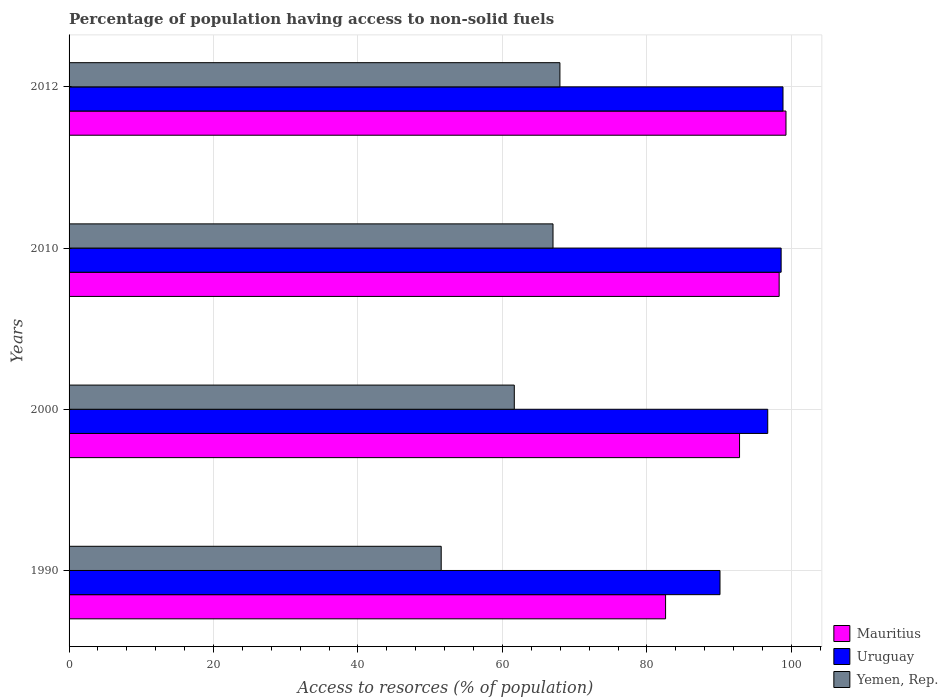How many groups of bars are there?
Your answer should be compact. 4. Are the number of bars on each tick of the Y-axis equal?
Your response must be concise. Yes. How many bars are there on the 1st tick from the top?
Give a very brief answer. 3. What is the label of the 2nd group of bars from the top?
Ensure brevity in your answer.  2010. In how many cases, is the number of bars for a given year not equal to the number of legend labels?
Make the answer very short. 0. What is the percentage of population having access to non-solid fuels in Mauritius in 2012?
Provide a short and direct response. 99.26. Across all years, what is the maximum percentage of population having access to non-solid fuels in Yemen, Rep.?
Ensure brevity in your answer.  67.96. Across all years, what is the minimum percentage of population having access to non-solid fuels in Uruguay?
Ensure brevity in your answer.  90.12. In which year was the percentage of population having access to non-solid fuels in Mauritius maximum?
Your answer should be compact. 2012. What is the total percentage of population having access to non-solid fuels in Uruguay in the graph?
Offer a very short reply. 384.29. What is the difference between the percentage of population having access to non-solid fuels in Uruguay in 1990 and that in 2012?
Keep it short and to the point. -8.72. What is the difference between the percentage of population having access to non-solid fuels in Yemen, Rep. in 1990 and the percentage of population having access to non-solid fuels in Uruguay in 2010?
Your answer should be very brief. -47.06. What is the average percentage of population having access to non-solid fuels in Uruguay per year?
Your answer should be compact. 96.07. In the year 2012, what is the difference between the percentage of population having access to non-solid fuels in Yemen, Rep. and percentage of population having access to non-solid fuels in Mauritius?
Make the answer very short. -31.3. In how many years, is the percentage of population having access to non-solid fuels in Uruguay greater than 4 %?
Make the answer very short. 4. What is the ratio of the percentage of population having access to non-solid fuels in Mauritius in 1990 to that in 2012?
Give a very brief answer. 0.83. Is the difference between the percentage of population having access to non-solid fuels in Yemen, Rep. in 1990 and 2000 greater than the difference between the percentage of population having access to non-solid fuels in Mauritius in 1990 and 2000?
Offer a terse response. Yes. What is the difference between the highest and the second highest percentage of population having access to non-solid fuels in Uruguay?
Ensure brevity in your answer.  0.26. What is the difference between the highest and the lowest percentage of population having access to non-solid fuels in Uruguay?
Ensure brevity in your answer.  8.72. In how many years, is the percentage of population having access to non-solid fuels in Uruguay greater than the average percentage of population having access to non-solid fuels in Uruguay taken over all years?
Your answer should be very brief. 3. Is the sum of the percentage of population having access to non-solid fuels in Uruguay in 1990 and 2000 greater than the maximum percentage of population having access to non-solid fuels in Yemen, Rep. across all years?
Give a very brief answer. Yes. What does the 3rd bar from the top in 2010 represents?
Your answer should be compact. Mauritius. What does the 2nd bar from the bottom in 1990 represents?
Your answer should be very brief. Uruguay. How many years are there in the graph?
Offer a very short reply. 4. What is the difference between two consecutive major ticks on the X-axis?
Make the answer very short. 20. Are the values on the major ticks of X-axis written in scientific E-notation?
Your response must be concise. No. Does the graph contain any zero values?
Your answer should be very brief. No. Does the graph contain grids?
Ensure brevity in your answer.  Yes. How many legend labels are there?
Offer a terse response. 3. What is the title of the graph?
Your response must be concise. Percentage of population having access to non-solid fuels. What is the label or title of the X-axis?
Provide a succinct answer. Access to resorces (% of population). What is the Access to resorces (% of population) in Mauritius in 1990?
Your answer should be very brief. 82.59. What is the Access to resorces (% of population) of Uruguay in 1990?
Give a very brief answer. 90.12. What is the Access to resorces (% of population) of Yemen, Rep. in 1990?
Keep it short and to the point. 51.52. What is the Access to resorces (% of population) in Mauritius in 2000?
Keep it short and to the point. 92.83. What is the Access to resorces (% of population) in Uruguay in 2000?
Your answer should be very brief. 96.73. What is the Access to resorces (% of population) of Yemen, Rep. in 2000?
Give a very brief answer. 61.64. What is the Access to resorces (% of population) of Mauritius in 2010?
Your response must be concise. 98.31. What is the Access to resorces (% of population) in Uruguay in 2010?
Keep it short and to the point. 98.59. What is the Access to resorces (% of population) of Yemen, Rep. in 2010?
Offer a very short reply. 67. What is the Access to resorces (% of population) in Mauritius in 2012?
Offer a terse response. 99.26. What is the Access to resorces (% of population) in Uruguay in 2012?
Keep it short and to the point. 98.85. What is the Access to resorces (% of population) of Yemen, Rep. in 2012?
Your answer should be very brief. 67.96. Across all years, what is the maximum Access to resorces (% of population) of Mauritius?
Your answer should be very brief. 99.26. Across all years, what is the maximum Access to resorces (% of population) of Uruguay?
Your answer should be very brief. 98.85. Across all years, what is the maximum Access to resorces (% of population) in Yemen, Rep.?
Your answer should be very brief. 67.96. Across all years, what is the minimum Access to resorces (% of population) in Mauritius?
Offer a very short reply. 82.59. Across all years, what is the minimum Access to resorces (% of population) of Uruguay?
Your response must be concise. 90.12. Across all years, what is the minimum Access to resorces (% of population) of Yemen, Rep.?
Offer a terse response. 51.52. What is the total Access to resorces (% of population) in Mauritius in the graph?
Your response must be concise. 372.99. What is the total Access to resorces (% of population) in Uruguay in the graph?
Provide a succinct answer. 384.29. What is the total Access to resorces (% of population) of Yemen, Rep. in the graph?
Ensure brevity in your answer.  248.13. What is the difference between the Access to resorces (% of population) of Mauritius in 1990 and that in 2000?
Provide a short and direct response. -10.24. What is the difference between the Access to resorces (% of population) of Uruguay in 1990 and that in 2000?
Your response must be concise. -6.61. What is the difference between the Access to resorces (% of population) in Yemen, Rep. in 1990 and that in 2000?
Offer a very short reply. -10.12. What is the difference between the Access to resorces (% of population) of Mauritius in 1990 and that in 2010?
Provide a succinct answer. -15.73. What is the difference between the Access to resorces (% of population) in Uruguay in 1990 and that in 2010?
Keep it short and to the point. -8.46. What is the difference between the Access to resorces (% of population) in Yemen, Rep. in 1990 and that in 2010?
Offer a very short reply. -15.48. What is the difference between the Access to resorces (% of population) in Mauritius in 1990 and that in 2012?
Ensure brevity in your answer.  -16.67. What is the difference between the Access to resorces (% of population) of Uruguay in 1990 and that in 2012?
Offer a very short reply. -8.72. What is the difference between the Access to resorces (% of population) in Yemen, Rep. in 1990 and that in 2012?
Offer a terse response. -16.44. What is the difference between the Access to resorces (% of population) of Mauritius in 2000 and that in 2010?
Your answer should be compact. -5.48. What is the difference between the Access to resorces (% of population) of Uruguay in 2000 and that in 2010?
Make the answer very short. -1.85. What is the difference between the Access to resorces (% of population) of Yemen, Rep. in 2000 and that in 2010?
Ensure brevity in your answer.  -5.36. What is the difference between the Access to resorces (% of population) of Mauritius in 2000 and that in 2012?
Offer a very short reply. -6.43. What is the difference between the Access to resorces (% of population) in Uruguay in 2000 and that in 2012?
Your response must be concise. -2.11. What is the difference between the Access to resorces (% of population) of Yemen, Rep. in 2000 and that in 2012?
Give a very brief answer. -6.32. What is the difference between the Access to resorces (% of population) in Mauritius in 2010 and that in 2012?
Your answer should be compact. -0.95. What is the difference between the Access to resorces (% of population) in Uruguay in 2010 and that in 2012?
Your answer should be compact. -0.26. What is the difference between the Access to resorces (% of population) in Yemen, Rep. in 2010 and that in 2012?
Ensure brevity in your answer.  -0.96. What is the difference between the Access to resorces (% of population) of Mauritius in 1990 and the Access to resorces (% of population) of Uruguay in 2000?
Give a very brief answer. -14.14. What is the difference between the Access to resorces (% of population) in Mauritius in 1990 and the Access to resorces (% of population) in Yemen, Rep. in 2000?
Your response must be concise. 20.94. What is the difference between the Access to resorces (% of population) in Uruguay in 1990 and the Access to resorces (% of population) in Yemen, Rep. in 2000?
Give a very brief answer. 28.48. What is the difference between the Access to resorces (% of population) of Mauritius in 1990 and the Access to resorces (% of population) of Uruguay in 2010?
Provide a succinct answer. -16. What is the difference between the Access to resorces (% of population) in Mauritius in 1990 and the Access to resorces (% of population) in Yemen, Rep. in 2010?
Your answer should be compact. 15.58. What is the difference between the Access to resorces (% of population) of Uruguay in 1990 and the Access to resorces (% of population) of Yemen, Rep. in 2010?
Keep it short and to the point. 23.12. What is the difference between the Access to resorces (% of population) in Mauritius in 1990 and the Access to resorces (% of population) in Uruguay in 2012?
Your answer should be very brief. -16.26. What is the difference between the Access to resorces (% of population) in Mauritius in 1990 and the Access to resorces (% of population) in Yemen, Rep. in 2012?
Give a very brief answer. 14.63. What is the difference between the Access to resorces (% of population) in Uruguay in 1990 and the Access to resorces (% of population) in Yemen, Rep. in 2012?
Offer a very short reply. 22.16. What is the difference between the Access to resorces (% of population) in Mauritius in 2000 and the Access to resorces (% of population) in Uruguay in 2010?
Provide a succinct answer. -5.76. What is the difference between the Access to resorces (% of population) in Mauritius in 2000 and the Access to resorces (% of population) in Yemen, Rep. in 2010?
Your response must be concise. 25.83. What is the difference between the Access to resorces (% of population) of Uruguay in 2000 and the Access to resorces (% of population) of Yemen, Rep. in 2010?
Give a very brief answer. 29.73. What is the difference between the Access to resorces (% of population) in Mauritius in 2000 and the Access to resorces (% of population) in Uruguay in 2012?
Provide a succinct answer. -6.02. What is the difference between the Access to resorces (% of population) in Mauritius in 2000 and the Access to resorces (% of population) in Yemen, Rep. in 2012?
Your answer should be very brief. 24.87. What is the difference between the Access to resorces (% of population) in Uruguay in 2000 and the Access to resorces (% of population) in Yemen, Rep. in 2012?
Your response must be concise. 28.77. What is the difference between the Access to resorces (% of population) in Mauritius in 2010 and the Access to resorces (% of population) in Uruguay in 2012?
Your answer should be very brief. -0.53. What is the difference between the Access to resorces (% of population) of Mauritius in 2010 and the Access to resorces (% of population) of Yemen, Rep. in 2012?
Make the answer very short. 30.35. What is the difference between the Access to resorces (% of population) of Uruguay in 2010 and the Access to resorces (% of population) of Yemen, Rep. in 2012?
Your response must be concise. 30.63. What is the average Access to resorces (% of population) in Mauritius per year?
Keep it short and to the point. 93.25. What is the average Access to resorces (% of population) in Uruguay per year?
Ensure brevity in your answer.  96.07. What is the average Access to resorces (% of population) in Yemen, Rep. per year?
Provide a short and direct response. 62.03. In the year 1990, what is the difference between the Access to resorces (% of population) in Mauritius and Access to resorces (% of population) in Uruguay?
Keep it short and to the point. -7.54. In the year 1990, what is the difference between the Access to resorces (% of population) of Mauritius and Access to resorces (% of population) of Yemen, Rep.?
Make the answer very short. 31.06. In the year 1990, what is the difference between the Access to resorces (% of population) of Uruguay and Access to resorces (% of population) of Yemen, Rep.?
Ensure brevity in your answer.  38.6. In the year 2000, what is the difference between the Access to resorces (% of population) in Mauritius and Access to resorces (% of population) in Uruguay?
Provide a succinct answer. -3.9. In the year 2000, what is the difference between the Access to resorces (% of population) of Mauritius and Access to resorces (% of population) of Yemen, Rep.?
Offer a terse response. 31.19. In the year 2000, what is the difference between the Access to resorces (% of population) in Uruguay and Access to resorces (% of population) in Yemen, Rep.?
Your answer should be very brief. 35.09. In the year 2010, what is the difference between the Access to resorces (% of population) of Mauritius and Access to resorces (% of population) of Uruguay?
Offer a terse response. -0.27. In the year 2010, what is the difference between the Access to resorces (% of population) of Mauritius and Access to resorces (% of population) of Yemen, Rep.?
Your response must be concise. 31.31. In the year 2010, what is the difference between the Access to resorces (% of population) of Uruguay and Access to resorces (% of population) of Yemen, Rep.?
Offer a very short reply. 31.58. In the year 2012, what is the difference between the Access to resorces (% of population) in Mauritius and Access to resorces (% of population) in Uruguay?
Give a very brief answer. 0.41. In the year 2012, what is the difference between the Access to resorces (% of population) of Mauritius and Access to resorces (% of population) of Yemen, Rep.?
Make the answer very short. 31.3. In the year 2012, what is the difference between the Access to resorces (% of population) of Uruguay and Access to resorces (% of population) of Yemen, Rep.?
Your answer should be very brief. 30.89. What is the ratio of the Access to resorces (% of population) in Mauritius in 1990 to that in 2000?
Offer a terse response. 0.89. What is the ratio of the Access to resorces (% of population) of Uruguay in 1990 to that in 2000?
Your answer should be very brief. 0.93. What is the ratio of the Access to resorces (% of population) of Yemen, Rep. in 1990 to that in 2000?
Ensure brevity in your answer.  0.84. What is the ratio of the Access to resorces (% of population) in Mauritius in 1990 to that in 2010?
Provide a short and direct response. 0.84. What is the ratio of the Access to resorces (% of population) in Uruguay in 1990 to that in 2010?
Offer a very short reply. 0.91. What is the ratio of the Access to resorces (% of population) of Yemen, Rep. in 1990 to that in 2010?
Your answer should be very brief. 0.77. What is the ratio of the Access to resorces (% of population) of Mauritius in 1990 to that in 2012?
Your answer should be compact. 0.83. What is the ratio of the Access to resorces (% of population) of Uruguay in 1990 to that in 2012?
Offer a very short reply. 0.91. What is the ratio of the Access to resorces (% of population) of Yemen, Rep. in 1990 to that in 2012?
Provide a succinct answer. 0.76. What is the ratio of the Access to resorces (% of population) of Mauritius in 2000 to that in 2010?
Provide a short and direct response. 0.94. What is the ratio of the Access to resorces (% of population) of Uruguay in 2000 to that in 2010?
Provide a succinct answer. 0.98. What is the ratio of the Access to resorces (% of population) of Yemen, Rep. in 2000 to that in 2010?
Your answer should be very brief. 0.92. What is the ratio of the Access to resorces (% of population) in Mauritius in 2000 to that in 2012?
Ensure brevity in your answer.  0.94. What is the ratio of the Access to resorces (% of population) in Uruguay in 2000 to that in 2012?
Provide a short and direct response. 0.98. What is the ratio of the Access to resorces (% of population) of Yemen, Rep. in 2000 to that in 2012?
Offer a terse response. 0.91. What is the ratio of the Access to resorces (% of population) in Yemen, Rep. in 2010 to that in 2012?
Your response must be concise. 0.99. What is the difference between the highest and the second highest Access to resorces (% of population) in Mauritius?
Make the answer very short. 0.95. What is the difference between the highest and the second highest Access to resorces (% of population) in Uruguay?
Offer a very short reply. 0.26. What is the difference between the highest and the second highest Access to resorces (% of population) in Yemen, Rep.?
Your answer should be very brief. 0.96. What is the difference between the highest and the lowest Access to resorces (% of population) in Mauritius?
Offer a terse response. 16.67. What is the difference between the highest and the lowest Access to resorces (% of population) in Uruguay?
Your response must be concise. 8.72. What is the difference between the highest and the lowest Access to resorces (% of population) of Yemen, Rep.?
Keep it short and to the point. 16.44. 